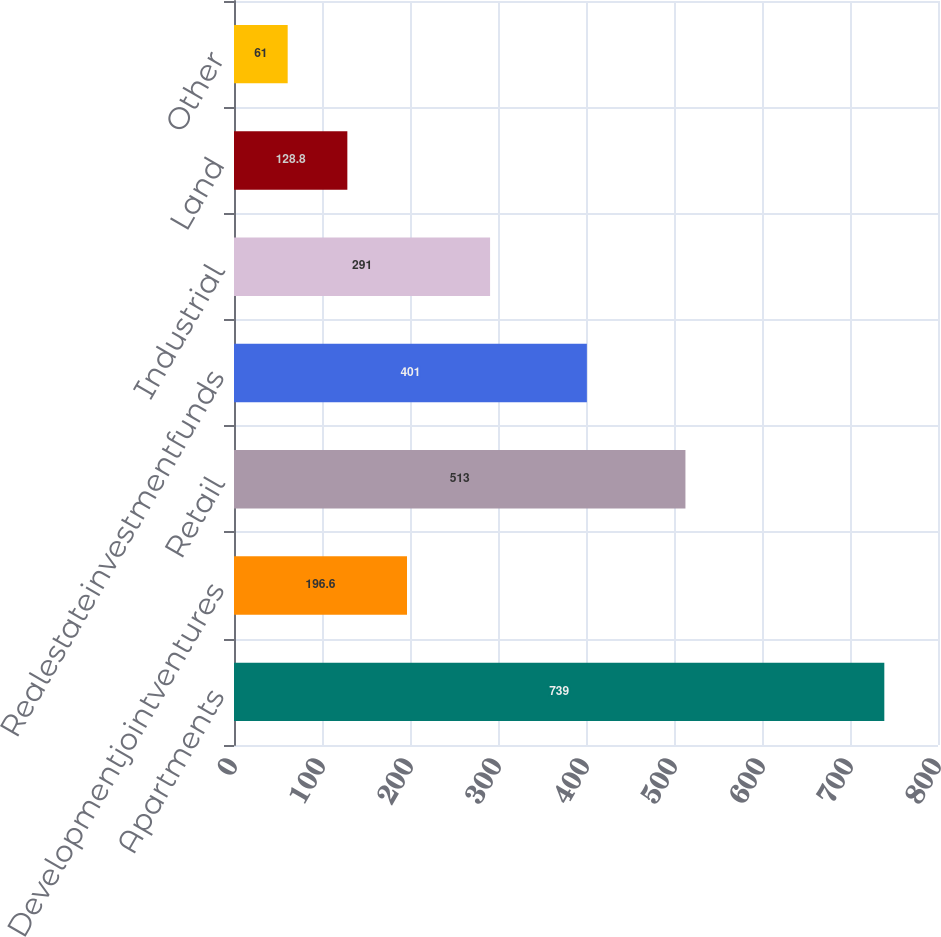Convert chart. <chart><loc_0><loc_0><loc_500><loc_500><bar_chart><fcel>Apartments<fcel>Developmentjointventures<fcel>Retail<fcel>Realestateinvestmentfunds<fcel>Industrial<fcel>Land<fcel>Other<nl><fcel>739<fcel>196.6<fcel>513<fcel>401<fcel>291<fcel>128.8<fcel>61<nl></chart> 